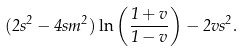Convert formula to latex. <formula><loc_0><loc_0><loc_500><loc_500>( 2 s ^ { 2 } - 4 s m ^ { 2 } ) \ln \left ( \frac { 1 + v } { 1 - v } \right ) - 2 v s ^ { 2 } .</formula> 